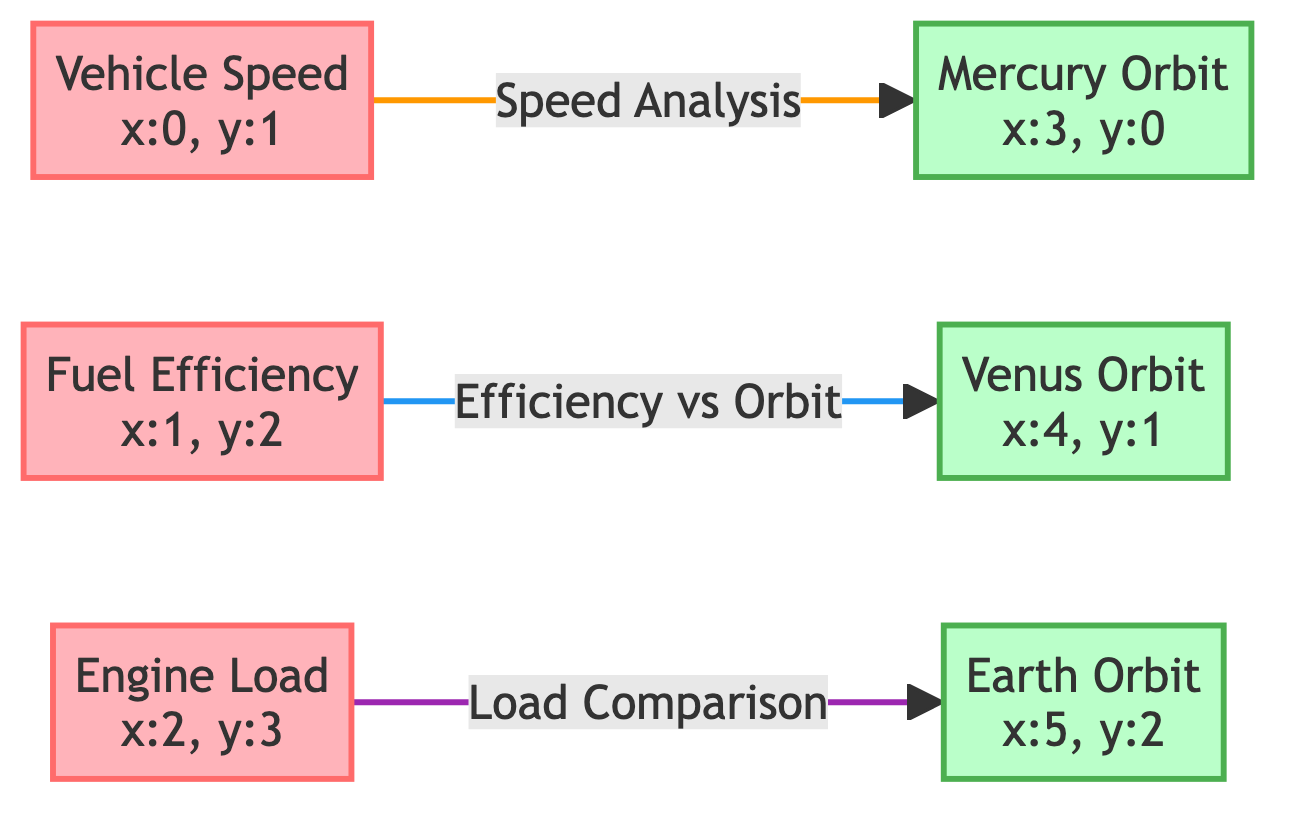What diagnostic metric is represented by the node labeled "VS"? The node labeled "VS" represents the diagnostic metric "Vehicle Speed." It is directly mentioned in the node label itself.
Answer: Vehicle Speed Which vehicle telemetry data node connects to "Venus Orbit"? The node "Fuel Efficiency" connects to "Venus Orbit." The directed link from "FE" points towards "VO."
Answer: Fuel Efficiency How many telemetry data nodes are there in the diagram? The diagram includes three telemetry data nodes: "Vehicle Speed," "Fuel Efficiency," and "Engine Load." Counting them gives a total of three nodes.
Answer: 3 What does the link style between "Engine Load" and "Earth Orbit" indicate? The link style between "Engine Load" and "Earth Orbit" is styled with a stroke color of "purple" (#9C27B0), indicating the nature of the analysis, which is focused on load comparison specifically.
Answer: Load Comparison What type of analysis is indicated by the arrow linking "Vehicle Speed" to "Mercury Orbit"? The arrow linking "Vehicle Speed" to "Mercury Orbit" indicates a "Speed Analysis." This is stated clearly in the directed link's label.
Answer: Speed Analysis Which planet's orbit is associated with the "Fuel Efficiency" metric? The planet's orbit associated with the "Fuel Efficiency" metric is "Venus Orbit," as indicated by the directed link from "Fuel Efficiency" to "Venus Orbit."
Answer: Venus Orbit What color represents the telemetry nodes in the diagram? The telemetry nodes are represented in a pink shade (#FFB3BA) as defined in the diagram class definition for telemetry nodes.
Answer: Pink Determine the edge type between "Engine Load" and "Earth Orbit." The edge type between "Engine Load" and "Earth Orbit" is a comparison style link as indicated by the labeled directed link which notes this as "Load Comparison."
Answer: Load Comparison Which orbital path is linked to "Fuel Efficiency" in the diagram? "Fuel Efficiency" is linked to the "Venus Orbit" indicated by the directed link from the corresponding telemetry node to the orbital path node.
Answer: Venus Orbit 